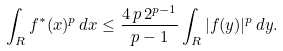Convert formula to latex. <formula><loc_0><loc_0><loc_500><loc_500>\int _ { R } f ^ { * } ( x ) ^ { p } \, d x \leq \frac { 4 \, p \, 2 ^ { p - 1 } } { p - 1 } \int _ { R } | f ( y ) | ^ { p } \, d y .</formula> 